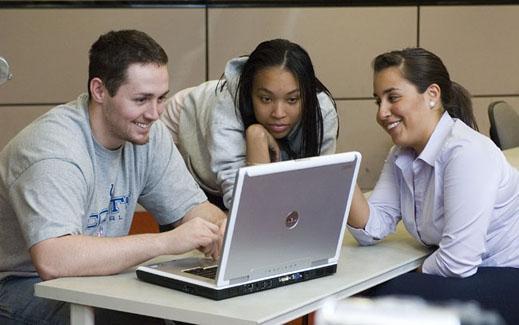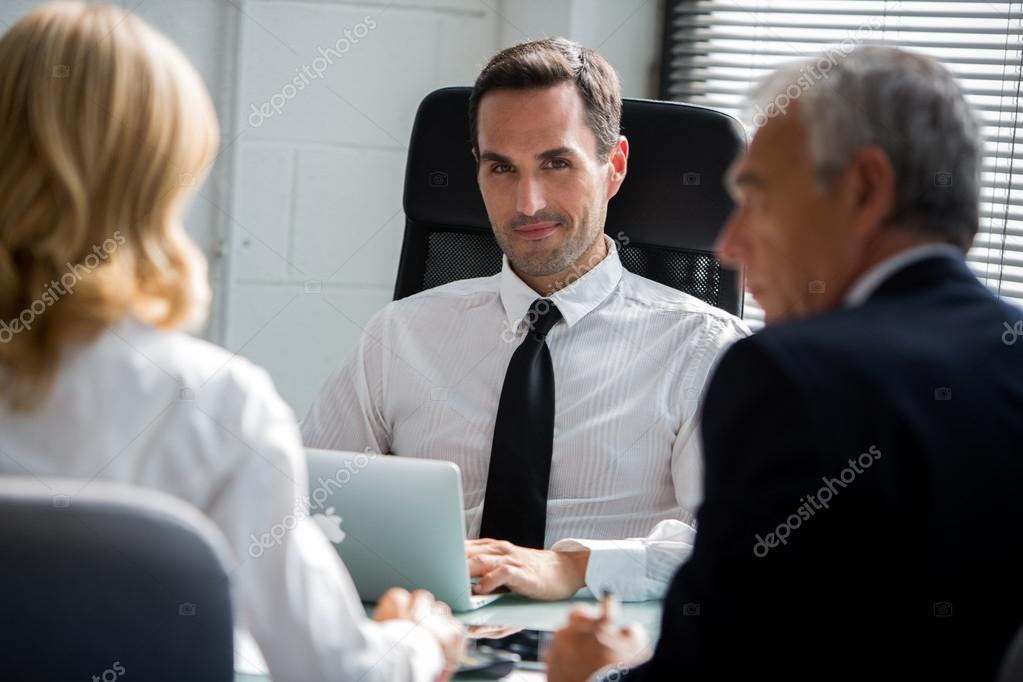The first image is the image on the left, the second image is the image on the right. Assess this claim about the two images: "The left image shows a person leaning in to look at an open laptop in front of a different person, and the right image includes a man in a necktie sitting behind a laptop.". Correct or not? Answer yes or no. Yes. The first image is the image on the left, the second image is the image on the right. Assess this claim about the two images: "The right image contains a man wearing a white shirt with a black tie.". Correct or not? Answer yes or no. Yes. 